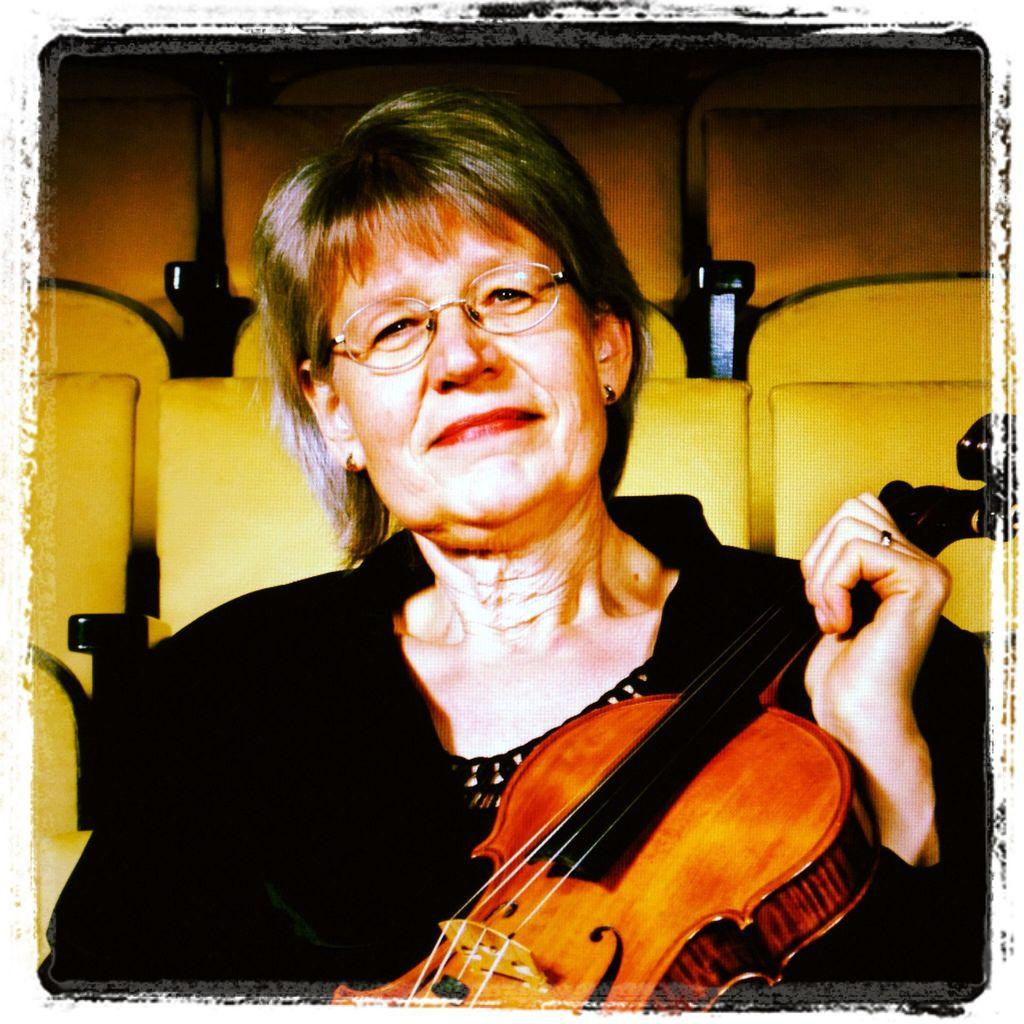What is the woman in the image holding? The woman is holding a guitar. What is the woman's facial expression in the image? The woman is smiling. What can be seen in the background of the image? There are yellow chairs in the background of the image. Are the chairs occupied or empty? The chairs are empty. What is the taste of the guitar in the image? Guitars do not have a taste, as they are musical instruments and not food items. 